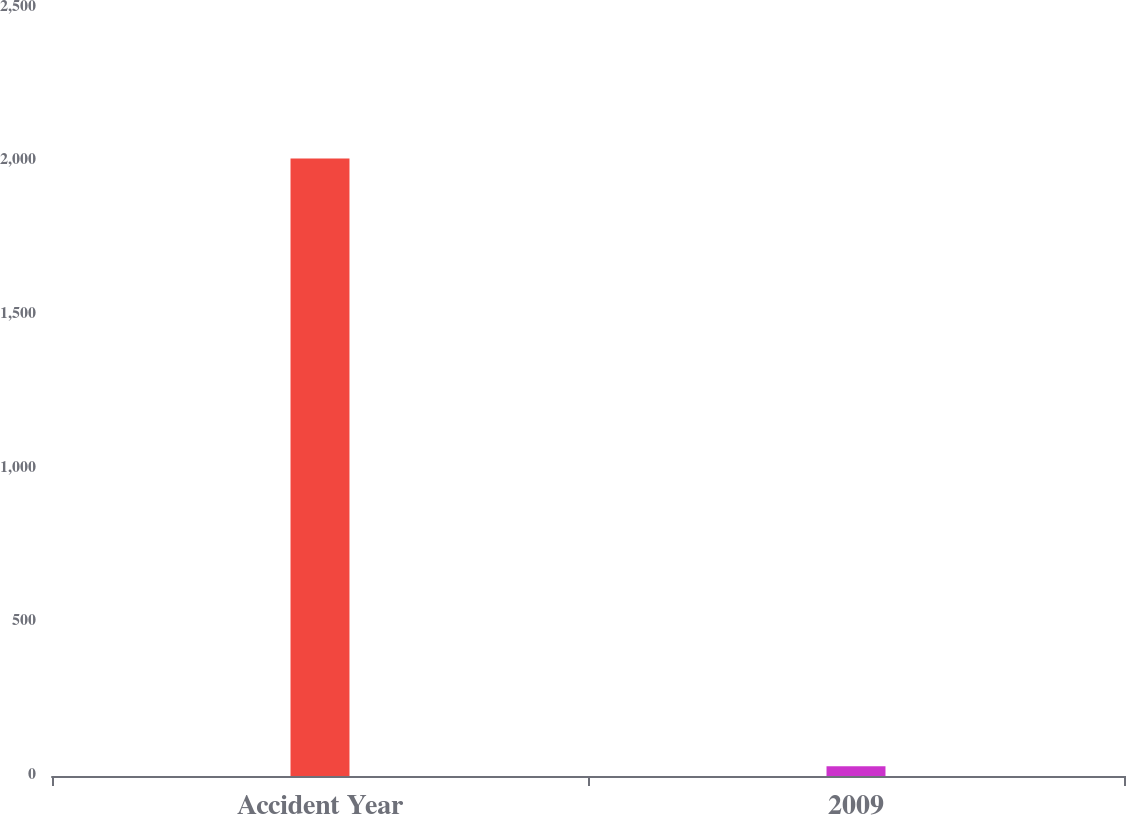Convert chart to OTSL. <chart><loc_0><loc_0><loc_500><loc_500><bar_chart><fcel>Accident Year<fcel>2009<nl><fcel>2010<fcel>32<nl></chart> 